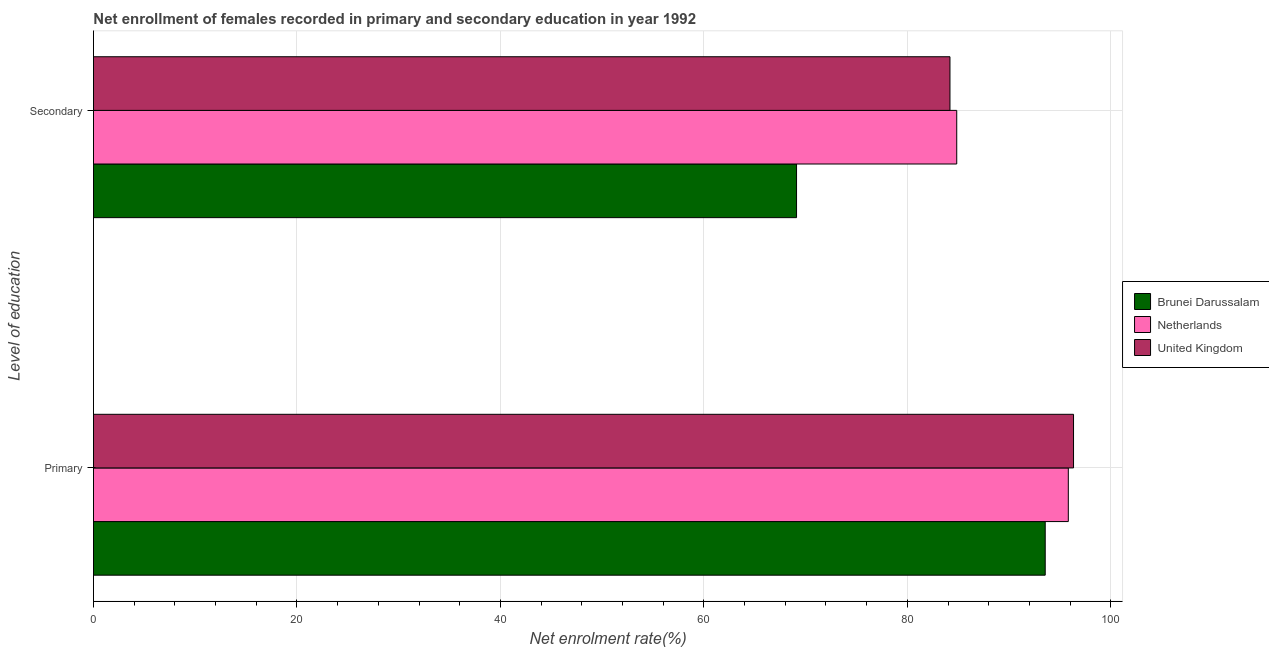How many groups of bars are there?
Your answer should be compact. 2. Are the number of bars per tick equal to the number of legend labels?
Provide a succinct answer. Yes. Are the number of bars on each tick of the Y-axis equal?
Your answer should be compact. Yes. What is the label of the 1st group of bars from the top?
Offer a terse response. Secondary. What is the enrollment rate in primary education in Netherlands?
Offer a terse response. 95.82. Across all countries, what is the maximum enrollment rate in secondary education?
Make the answer very short. 84.86. Across all countries, what is the minimum enrollment rate in primary education?
Give a very brief answer. 93.55. In which country was the enrollment rate in primary education minimum?
Ensure brevity in your answer.  Brunei Darussalam. What is the total enrollment rate in primary education in the graph?
Your answer should be very brief. 285.71. What is the difference between the enrollment rate in secondary education in Netherlands and that in Brunei Darussalam?
Your answer should be compact. 15.75. What is the difference between the enrollment rate in primary education in Netherlands and the enrollment rate in secondary education in Brunei Darussalam?
Provide a short and direct response. 26.71. What is the average enrollment rate in secondary education per country?
Provide a succinct answer. 79.39. What is the difference between the enrollment rate in secondary education and enrollment rate in primary education in United Kingdom?
Ensure brevity in your answer.  -12.15. In how many countries, is the enrollment rate in primary education greater than 40 %?
Offer a very short reply. 3. What is the ratio of the enrollment rate in secondary education in United Kingdom to that in Netherlands?
Offer a very short reply. 0.99. What does the 3rd bar from the bottom in Secondary represents?
Offer a terse response. United Kingdom. How many bars are there?
Offer a terse response. 6. How many countries are there in the graph?
Give a very brief answer. 3. What is the difference between two consecutive major ticks on the X-axis?
Give a very brief answer. 20. Does the graph contain grids?
Ensure brevity in your answer.  Yes. Where does the legend appear in the graph?
Make the answer very short. Center right. How many legend labels are there?
Provide a succinct answer. 3. What is the title of the graph?
Keep it short and to the point. Net enrollment of females recorded in primary and secondary education in year 1992. What is the label or title of the X-axis?
Give a very brief answer. Net enrolment rate(%). What is the label or title of the Y-axis?
Provide a short and direct response. Level of education. What is the Net enrolment rate(%) in Brunei Darussalam in Primary?
Your answer should be very brief. 93.55. What is the Net enrolment rate(%) of Netherlands in Primary?
Make the answer very short. 95.82. What is the Net enrolment rate(%) in United Kingdom in Primary?
Provide a succinct answer. 96.34. What is the Net enrolment rate(%) in Brunei Darussalam in Secondary?
Provide a short and direct response. 69.11. What is the Net enrolment rate(%) in Netherlands in Secondary?
Give a very brief answer. 84.86. What is the Net enrolment rate(%) of United Kingdom in Secondary?
Provide a short and direct response. 84.19. Across all Level of education, what is the maximum Net enrolment rate(%) of Brunei Darussalam?
Make the answer very short. 93.55. Across all Level of education, what is the maximum Net enrolment rate(%) in Netherlands?
Provide a succinct answer. 95.82. Across all Level of education, what is the maximum Net enrolment rate(%) of United Kingdom?
Give a very brief answer. 96.34. Across all Level of education, what is the minimum Net enrolment rate(%) in Brunei Darussalam?
Offer a very short reply. 69.11. Across all Level of education, what is the minimum Net enrolment rate(%) in Netherlands?
Ensure brevity in your answer.  84.86. Across all Level of education, what is the minimum Net enrolment rate(%) in United Kingdom?
Your response must be concise. 84.19. What is the total Net enrolment rate(%) in Brunei Darussalam in the graph?
Offer a very short reply. 162.66. What is the total Net enrolment rate(%) in Netherlands in the graph?
Keep it short and to the point. 180.68. What is the total Net enrolment rate(%) of United Kingdom in the graph?
Provide a succinct answer. 180.53. What is the difference between the Net enrolment rate(%) in Brunei Darussalam in Primary and that in Secondary?
Your response must be concise. 24.44. What is the difference between the Net enrolment rate(%) of Netherlands in Primary and that in Secondary?
Ensure brevity in your answer.  10.97. What is the difference between the Net enrolment rate(%) of United Kingdom in Primary and that in Secondary?
Give a very brief answer. 12.15. What is the difference between the Net enrolment rate(%) of Brunei Darussalam in Primary and the Net enrolment rate(%) of Netherlands in Secondary?
Your response must be concise. 8.7. What is the difference between the Net enrolment rate(%) of Brunei Darussalam in Primary and the Net enrolment rate(%) of United Kingdom in Secondary?
Provide a succinct answer. 9.36. What is the difference between the Net enrolment rate(%) in Netherlands in Primary and the Net enrolment rate(%) in United Kingdom in Secondary?
Give a very brief answer. 11.63. What is the average Net enrolment rate(%) of Brunei Darussalam per Level of education?
Ensure brevity in your answer.  81.33. What is the average Net enrolment rate(%) in Netherlands per Level of education?
Give a very brief answer. 90.34. What is the average Net enrolment rate(%) in United Kingdom per Level of education?
Your answer should be very brief. 90.26. What is the difference between the Net enrolment rate(%) in Brunei Darussalam and Net enrolment rate(%) in Netherlands in Primary?
Give a very brief answer. -2.27. What is the difference between the Net enrolment rate(%) in Brunei Darussalam and Net enrolment rate(%) in United Kingdom in Primary?
Your answer should be very brief. -2.78. What is the difference between the Net enrolment rate(%) in Netherlands and Net enrolment rate(%) in United Kingdom in Primary?
Keep it short and to the point. -0.51. What is the difference between the Net enrolment rate(%) of Brunei Darussalam and Net enrolment rate(%) of Netherlands in Secondary?
Keep it short and to the point. -15.75. What is the difference between the Net enrolment rate(%) of Brunei Darussalam and Net enrolment rate(%) of United Kingdom in Secondary?
Offer a very short reply. -15.08. What is the difference between the Net enrolment rate(%) in Netherlands and Net enrolment rate(%) in United Kingdom in Secondary?
Give a very brief answer. 0.66. What is the ratio of the Net enrolment rate(%) in Brunei Darussalam in Primary to that in Secondary?
Provide a succinct answer. 1.35. What is the ratio of the Net enrolment rate(%) of Netherlands in Primary to that in Secondary?
Your answer should be compact. 1.13. What is the ratio of the Net enrolment rate(%) of United Kingdom in Primary to that in Secondary?
Ensure brevity in your answer.  1.14. What is the difference between the highest and the second highest Net enrolment rate(%) in Brunei Darussalam?
Provide a succinct answer. 24.44. What is the difference between the highest and the second highest Net enrolment rate(%) of Netherlands?
Provide a succinct answer. 10.97. What is the difference between the highest and the second highest Net enrolment rate(%) in United Kingdom?
Give a very brief answer. 12.15. What is the difference between the highest and the lowest Net enrolment rate(%) of Brunei Darussalam?
Your response must be concise. 24.44. What is the difference between the highest and the lowest Net enrolment rate(%) in Netherlands?
Offer a terse response. 10.97. What is the difference between the highest and the lowest Net enrolment rate(%) of United Kingdom?
Your answer should be very brief. 12.15. 